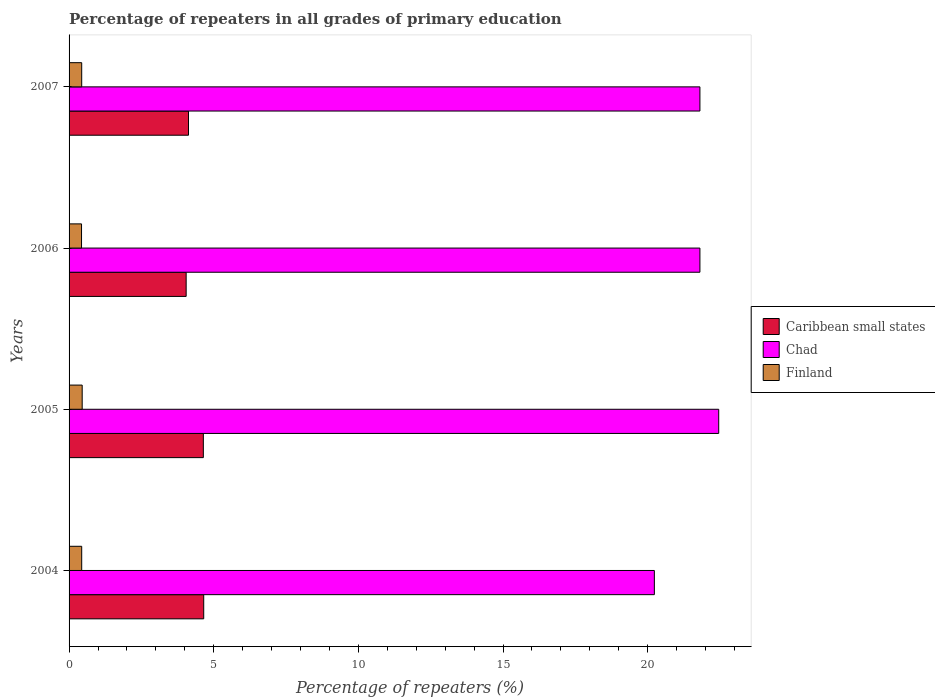How many groups of bars are there?
Your answer should be very brief. 4. Are the number of bars per tick equal to the number of legend labels?
Your answer should be compact. Yes. How many bars are there on the 1st tick from the top?
Your answer should be very brief. 3. How many bars are there on the 3rd tick from the bottom?
Your answer should be compact. 3. What is the percentage of repeaters in Finland in 2006?
Give a very brief answer. 0.43. Across all years, what is the maximum percentage of repeaters in Finland?
Give a very brief answer. 0.45. Across all years, what is the minimum percentage of repeaters in Chad?
Your answer should be very brief. 20.23. In which year was the percentage of repeaters in Caribbean small states minimum?
Your response must be concise. 2006. What is the total percentage of repeaters in Chad in the graph?
Provide a succinct answer. 86.29. What is the difference between the percentage of repeaters in Finland in 2004 and that in 2007?
Offer a very short reply. 0. What is the difference between the percentage of repeaters in Caribbean small states in 2004 and the percentage of repeaters in Chad in 2005?
Give a very brief answer. -17.8. What is the average percentage of repeaters in Caribbean small states per year?
Offer a very short reply. 4.37. In the year 2005, what is the difference between the percentage of repeaters in Chad and percentage of repeaters in Finland?
Provide a short and direct response. 22. In how many years, is the percentage of repeaters in Finland greater than 8 %?
Keep it short and to the point. 0. What is the ratio of the percentage of repeaters in Caribbean small states in 2004 to that in 2007?
Your response must be concise. 1.13. Is the percentage of repeaters in Chad in 2005 less than that in 2006?
Provide a succinct answer. No. Is the difference between the percentage of repeaters in Chad in 2005 and 2006 greater than the difference between the percentage of repeaters in Finland in 2005 and 2006?
Give a very brief answer. Yes. What is the difference between the highest and the second highest percentage of repeaters in Caribbean small states?
Your answer should be very brief. 0.01. What is the difference between the highest and the lowest percentage of repeaters in Finland?
Your answer should be compact. 0.02. What does the 1st bar from the bottom in 2005 represents?
Ensure brevity in your answer.  Caribbean small states. Is it the case that in every year, the sum of the percentage of repeaters in Chad and percentage of repeaters in Finland is greater than the percentage of repeaters in Caribbean small states?
Ensure brevity in your answer.  Yes. How many bars are there?
Make the answer very short. 12. Does the graph contain grids?
Offer a terse response. No. How are the legend labels stacked?
Keep it short and to the point. Vertical. What is the title of the graph?
Ensure brevity in your answer.  Percentage of repeaters in all grades of primary education. Does "United Kingdom" appear as one of the legend labels in the graph?
Keep it short and to the point. No. What is the label or title of the X-axis?
Your response must be concise. Percentage of repeaters (%). What is the label or title of the Y-axis?
Provide a succinct answer. Years. What is the Percentage of repeaters (%) in Caribbean small states in 2004?
Make the answer very short. 4.65. What is the Percentage of repeaters (%) in Chad in 2004?
Make the answer very short. 20.23. What is the Percentage of repeaters (%) in Finland in 2004?
Keep it short and to the point. 0.44. What is the Percentage of repeaters (%) of Caribbean small states in 2005?
Your response must be concise. 4.64. What is the Percentage of repeaters (%) of Chad in 2005?
Your answer should be compact. 22.45. What is the Percentage of repeaters (%) in Finland in 2005?
Provide a succinct answer. 0.45. What is the Percentage of repeaters (%) of Caribbean small states in 2006?
Provide a succinct answer. 4.05. What is the Percentage of repeaters (%) in Chad in 2006?
Your response must be concise. 21.81. What is the Percentage of repeaters (%) of Finland in 2006?
Provide a short and direct response. 0.43. What is the Percentage of repeaters (%) in Caribbean small states in 2007?
Provide a succinct answer. 4.13. What is the Percentage of repeaters (%) in Chad in 2007?
Offer a very short reply. 21.8. What is the Percentage of repeaters (%) of Finland in 2007?
Keep it short and to the point. 0.44. Across all years, what is the maximum Percentage of repeaters (%) of Caribbean small states?
Your response must be concise. 4.65. Across all years, what is the maximum Percentage of repeaters (%) in Chad?
Offer a very short reply. 22.45. Across all years, what is the maximum Percentage of repeaters (%) in Finland?
Ensure brevity in your answer.  0.45. Across all years, what is the minimum Percentage of repeaters (%) in Caribbean small states?
Keep it short and to the point. 4.05. Across all years, what is the minimum Percentage of repeaters (%) in Chad?
Offer a very short reply. 20.23. Across all years, what is the minimum Percentage of repeaters (%) in Finland?
Your answer should be compact. 0.43. What is the total Percentage of repeaters (%) in Caribbean small states in the graph?
Ensure brevity in your answer.  17.47. What is the total Percentage of repeaters (%) of Chad in the graph?
Ensure brevity in your answer.  86.29. What is the total Percentage of repeaters (%) of Finland in the graph?
Your answer should be compact. 1.76. What is the difference between the Percentage of repeaters (%) in Caribbean small states in 2004 and that in 2005?
Give a very brief answer. 0.01. What is the difference between the Percentage of repeaters (%) in Chad in 2004 and that in 2005?
Provide a short and direct response. -2.22. What is the difference between the Percentage of repeaters (%) of Finland in 2004 and that in 2005?
Ensure brevity in your answer.  -0.02. What is the difference between the Percentage of repeaters (%) of Caribbean small states in 2004 and that in 2006?
Provide a short and direct response. 0.61. What is the difference between the Percentage of repeaters (%) in Chad in 2004 and that in 2006?
Offer a terse response. -1.57. What is the difference between the Percentage of repeaters (%) of Finland in 2004 and that in 2006?
Ensure brevity in your answer.  0.01. What is the difference between the Percentage of repeaters (%) in Caribbean small states in 2004 and that in 2007?
Offer a terse response. 0.53. What is the difference between the Percentage of repeaters (%) in Chad in 2004 and that in 2007?
Your answer should be very brief. -1.57. What is the difference between the Percentage of repeaters (%) of Finland in 2004 and that in 2007?
Offer a terse response. 0. What is the difference between the Percentage of repeaters (%) of Caribbean small states in 2005 and that in 2006?
Your answer should be compact. 0.59. What is the difference between the Percentage of repeaters (%) in Chad in 2005 and that in 2006?
Keep it short and to the point. 0.65. What is the difference between the Percentage of repeaters (%) in Finland in 2005 and that in 2006?
Make the answer very short. 0.02. What is the difference between the Percentage of repeaters (%) of Caribbean small states in 2005 and that in 2007?
Give a very brief answer. 0.51. What is the difference between the Percentage of repeaters (%) of Chad in 2005 and that in 2007?
Make the answer very short. 0.65. What is the difference between the Percentage of repeaters (%) in Finland in 2005 and that in 2007?
Make the answer very short. 0.02. What is the difference between the Percentage of repeaters (%) in Caribbean small states in 2006 and that in 2007?
Your answer should be very brief. -0.08. What is the difference between the Percentage of repeaters (%) in Finland in 2006 and that in 2007?
Keep it short and to the point. -0.01. What is the difference between the Percentage of repeaters (%) of Caribbean small states in 2004 and the Percentage of repeaters (%) of Chad in 2005?
Your answer should be compact. -17.8. What is the difference between the Percentage of repeaters (%) of Caribbean small states in 2004 and the Percentage of repeaters (%) of Finland in 2005?
Offer a very short reply. 4.2. What is the difference between the Percentage of repeaters (%) of Chad in 2004 and the Percentage of repeaters (%) of Finland in 2005?
Your answer should be very brief. 19.78. What is the difference between the Percentage of repeaters (%) in Caribbean small states in 2004 and the Percentage of repeaters (%) in Chad in 2006?
Provide a short and direct response. -17.15. What is the difference between the Percentage of repeaters (%) of Caribbean small states in 2004 and the Percentage of repeaters (%) of Finland in 2006?
Provide a succinct answer. 4.22. What is the difference between the Percentage of repeaters (%) in Chad in 2004 and the Percentage of repeaters (%) in Finland in 2006?
Give a very brief answer. 19.8. What is the difference between the Percentage of repeaters (%) in Caribbean small states in 2004 and the Percentage of repeaters (%) in Chad in 2007?
Give a very brief answer. -17.15. What is the difference between the Percentage of repeaters (%) of Caribbean small states in 2004 and the Percentage of repeaters (%) of Finland in 2007?
Offer a very short reply. 4.22. What is the difference between the Percentage of repeaters (%) in Chad in 2004 and the Percentage of repeaters (%) in Finland in 2007?
Ensure brevity in your answer.  19.79. What is the difference between the Percentage of repeaters (%) of Caribbean small states in 2005 and the Percentage of repeaters (%) of Chad in 2006?
Keep it short and to the point. -17.16. What is the difference between the Percentage of repeaters (%) of Caribbean small states in 2005 and the Percentage of repeaters (%) of Finland in 2006?
Provide a short and direct response. 4.21. What is the difference between the Percentage of repeaters (%) of Chad in 2005 and the Percentage of repeaters (%) of Finland in 2006?
Offer a terse response. 22.02. What is the difference between the Percentage of repeaters (%) of Caribbean small states in 2005 and the Percentage of repeaters (%) of Chad in 2007?
Provide a succinct answer. -17.16. What is the difference between the Percentage of repeaters (%) of Caribbean small states in 2005 and the Percentage of repeaters (%) of Finland in 2007?
Give a very brief answer. 4.2. What is the difference between the Percentage of repeaters (%) of Chad in 2005 and the Percentage of repeaters (%) of Finland in 2007?
Your answer should be compact. 22.02. What is the difference between the Percentage of repeaters (%) of Caribbean small states in 2006 and the Percentage of repeaters (%) of Chad in 2007?
Provide a succinct answer. -17.76. What is the difference between the Percentage of repeaters (%) of Caribbean small states in 2006 and the Percentage of repeaters (%) of Finland in 2007?
Keep it short and to the point. 3.61. What is the difference between the Percentage of repeaters (%) of Chad in 2006 and the Percentage of repeaters (%) of Finland in 2007?
Offer a very short reply. 21.37. What is the average Percentage of repeaters (%) in Caribbean small states per year?
Make the answer very short. 4.37. What is the average Percentage of repeaters (%) of Chad per year?
Provide a succinct answer. 21.57. What is the average Percentage of repeaters (%) in Finland per year?
Make the answer very short. 0.44. In the year 2004, what is the difference between the Percentage of repeaters (%) of Caribbean small states and Percentage of repeaters (%) of Chad?
Give a very brief answer. -15.58. In the year 2004, what is the difference between the Percentage of repeaters (%) in Caribbean small states and Percentage of repeaters (%) in Finland?
Make the answer very short. 4.22. In the year 2004, what is the difference between the Percentage of repeaters (%) of Chad and Percentage of repeaters (%) of Finland?
Provide a short and direct response. 19.79. In the year 2005, what is the difference between the Percentage of repeaters (%) in Caribbean small states and Percentage of repeaters (%) in Chad?
Give a very brief answer. -17.81. In the year 2005, what is the difference between the Percentage of repeaters (%) of Caribbean small states and Percentage of repeaters (%) of Finland?
Provide a short and direct response. 4.19. In the year 2005, what is the difference between the Percentage of repeaters (%) in Chad and Percentage of repeaters (%) in Finland?
Give a very brief answer. 22. In the year 2006, what is the difference between the Percentage of repeaters (%) in Caribbean small states and Percentage of repeaters (%) in Chad?
Offer a terse response. -17.76. In the year 2006, what is the difference between the Percentage of repeaters (%) of Caribbean small states and Percentage of repeaters (%) of Finland?
Provide a short and direct response. 3.62. In the year 2006, what is the difference between the Percentage of repeaters (%) in Chad and Percentage of repeaters (%) in Finland?
Ensure brevity in your answer.  21.37. In the year 2007, what is the difference between the Percentage of repeaters (%) of Caribbean small states and Percentage of repeaters (%) of Chad?
Offer a terse response. -17.68. In the year 2007, what is the difference between the Percentage of repeaters (%) of Caribbean small states and Percentage of repeaters (%) of Finland?
Give a very brief answer. 3.69. In the year 2007, what is the difference between the Percentage of repeaters (%) of Chad and Percentage of repeaters (%) of Finland?
Offer a terse response. 21.37. What is the ratio of the Percentage of repeaters (%) in Chad in 2004 to that in 2005?
Provide a short and direct response. 0.9. What is the ratio of the Percentage of repeaters (%) in Finland in 2004 to that in 2005?
Your answer should be very brief. 0.96. What is the ratio of the Percentage of repeaters (%) of Caribbean small states in 2004 to that in 2006?
Make the answer very short. 1.15. What is the ratio of the Percentage of repeaters (%) in Chad in 2004 to that in 2006?
Offer a terse response. 0.93. What is the ratio of the Percentage of repeaters (%) in Finland in 2004 to that in 2006?
Your answer should be very brief. 1.01. What is the ratio of the Percentage of repeaters (%) in Caribbean small states in 2004 to that in 2007?
Your answer should be very brief. 1.13. What is the ratio of the Percentage of repeaters (%) in Chad in 2004 to that in 2007?
Make the answer very short. 0.93. What is the ratio of the Percentage of repeaters (%) of Finland in 2004 to that in 2007?
Provide a short and direct response. 1. What is the ratio of the Percentage of repeaters (%) of Caribbean small states in 2005 to that in 2006?
Ensure brevity in your answer.  1.15. What is the ratio of the Percentage of repeaters (%) of Chad in 2005 to that in 2006?
Your response must be concise. 1.03. What is the ratio of the Percentage of repeaters (%) in Finland in 2005 to that in 2006?
Your answer should be compact. 1.05. What is the ratio of the Percentage of repeaters (%) of Caribbean small states in 2005 to that in 2007?
Provide a short and direct response. 1.12. What is the ratio of the Percentage of repeaters (%) in Chad in 2005 to that in 2007?
Give a very brief answer. 1.03. What is the ratio of the Percentage of repeaters (%) in Finland in 2005 to that in 2007?
Your response must be concise. 1.04. What is the ratio of the Percentage of repeaters (%) in Caribbean small states in 2006 to that in 2007?
Your response must be concise. 0.98. What is the ratio of the Percentage of repeaters (%) of Chad in 2006 to that in 2007?
Your answer should be compact. 1. What is the ratio of the Percentage of repeaters (%) in Finland in 2006 to that in 2007?
Keep it short and to the point. 0.99. What is the difference between the highest and the second highest Percentage of repeaters (%) of Caribbean small states?
Your response must be concise. 0.01. What is the difference between the highest and the second highest Percentage of repeaters (%) in Chad?
Offer a terse response. 0.65. What is the difference between the highest and the second highest Percentage of repeaters (%) of Finland?
Make the answer very short. 0.02. What is the difference between the highest and the lowest Percentage of repeaters (%) in Caribbean small states?
Ensure brevity in your answer.  0.61. What is the difference between the highest and the lowest Percentage of repeaters (%) of Chad?
Your response must be concise. 2.22. What is the difference between the highest and the lowest Percentage of repeaters (%) of Finland?
Make the answer very short. 0.02. 